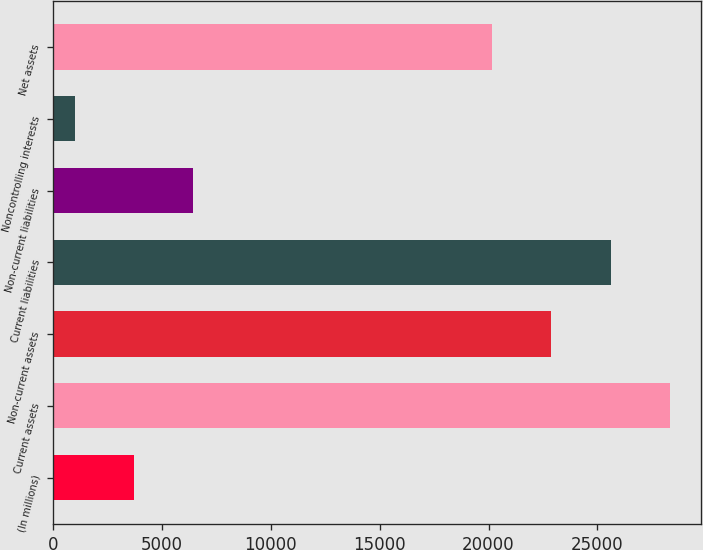Convert chart. <chart><loc_0><loc_0><loc_500><loc_500><bar_chart><fcel>(In millions)<fcel>Current assets<fcel>Non-current assets<fcel>Current liabilities<fcel>Non-current liabilities<fcel>Noncontrolling interests<fcel>Net assets<nl><fcel>3702.9<fcel>28336.7<fcel>22892.9<fcel>25614.8<fcel>6424.8<fcel>981<fcel>20171<nl></chart> 